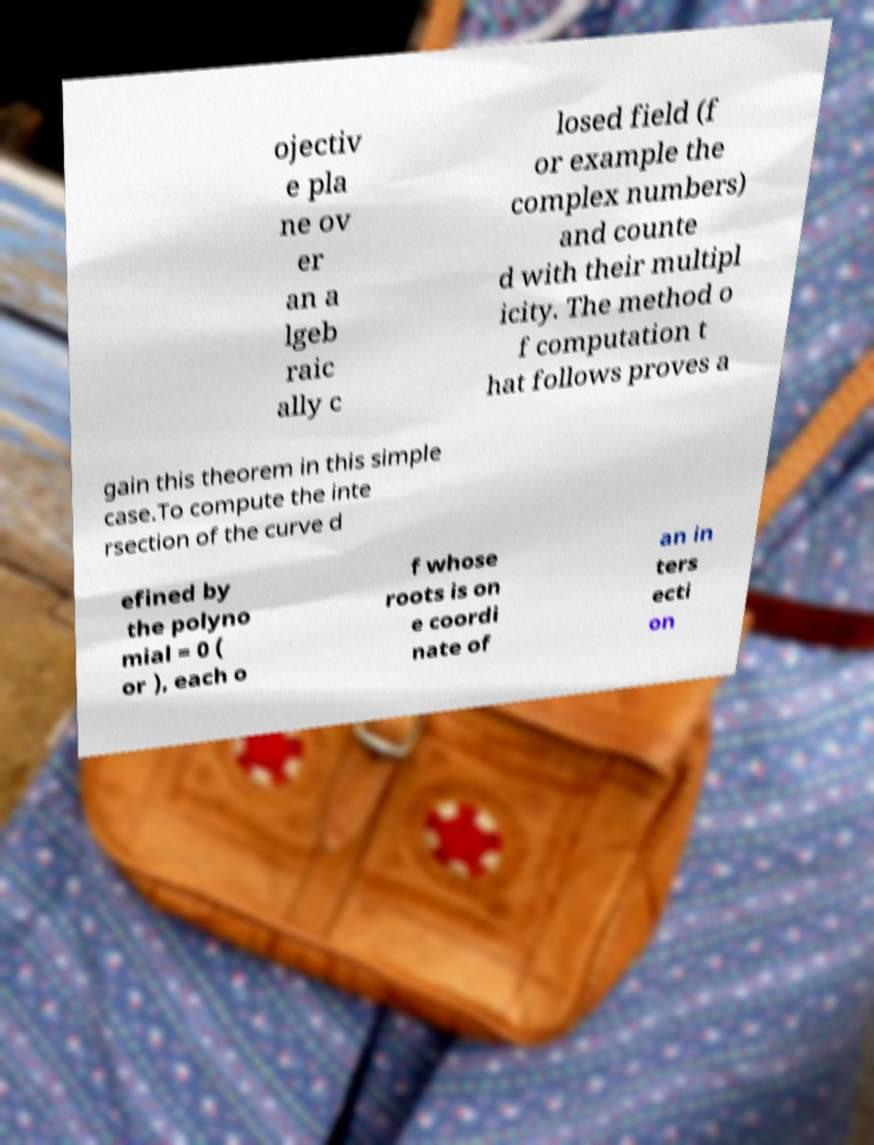Could you extract and type out the text from this image? ojectiv e pla ne ov er an a lgeb raic ally c losed field (f or example the complex numbers) and counte d with their multipl icity. The method o f computation t hat follows proves a gain this theorem in this simple case.To compute the inte rsection of the curve d efined by the polyno mial = 0 ( or ), each o f whose roots is on e coordi nate of an in ters ecti on 